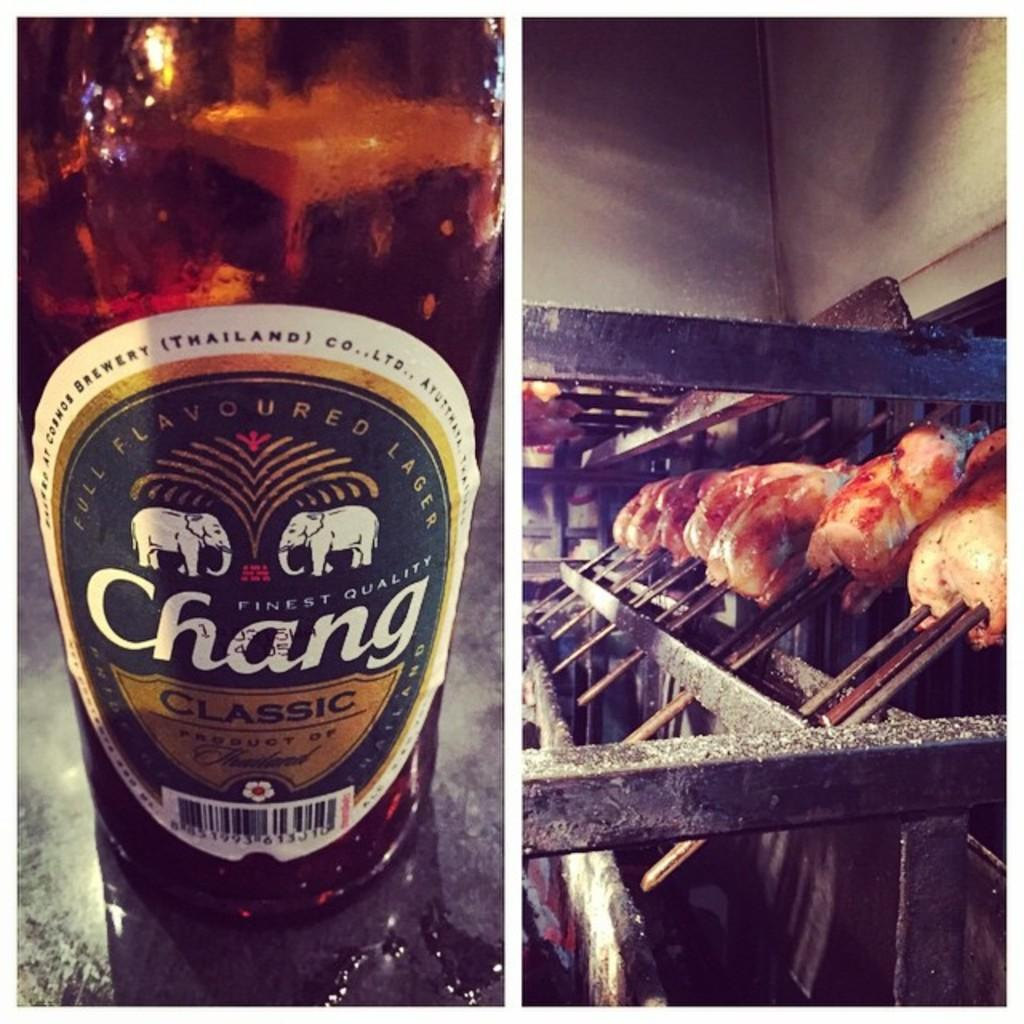How many pictures are included in the collage? The image is a collage with two distinct pictures. What is featured in the first picture? In the first picture, there is an alcohol bottle. What is happening in the second picture? In the second picture, there is a scene of chicken being fried in a barbecue machine. What type of muscle is being exercised by the dad in the image? There is no dad or muscle present in the image; it features an alcohol bottle and a scene of chicken being fried in a barbecue machine. 